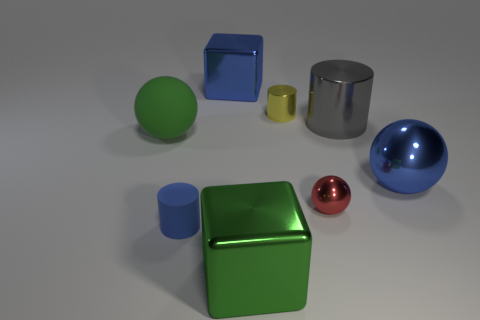Do the big metallic ball and the cylinder that is to the left of the small metallic cylinder have the same color? The big metallic ball and the cylinder to the left of the small metallic cylinder appear to share a similar shade of silver, which gives them a somewhat matching appearance due to their reflective metallic surfaces. 